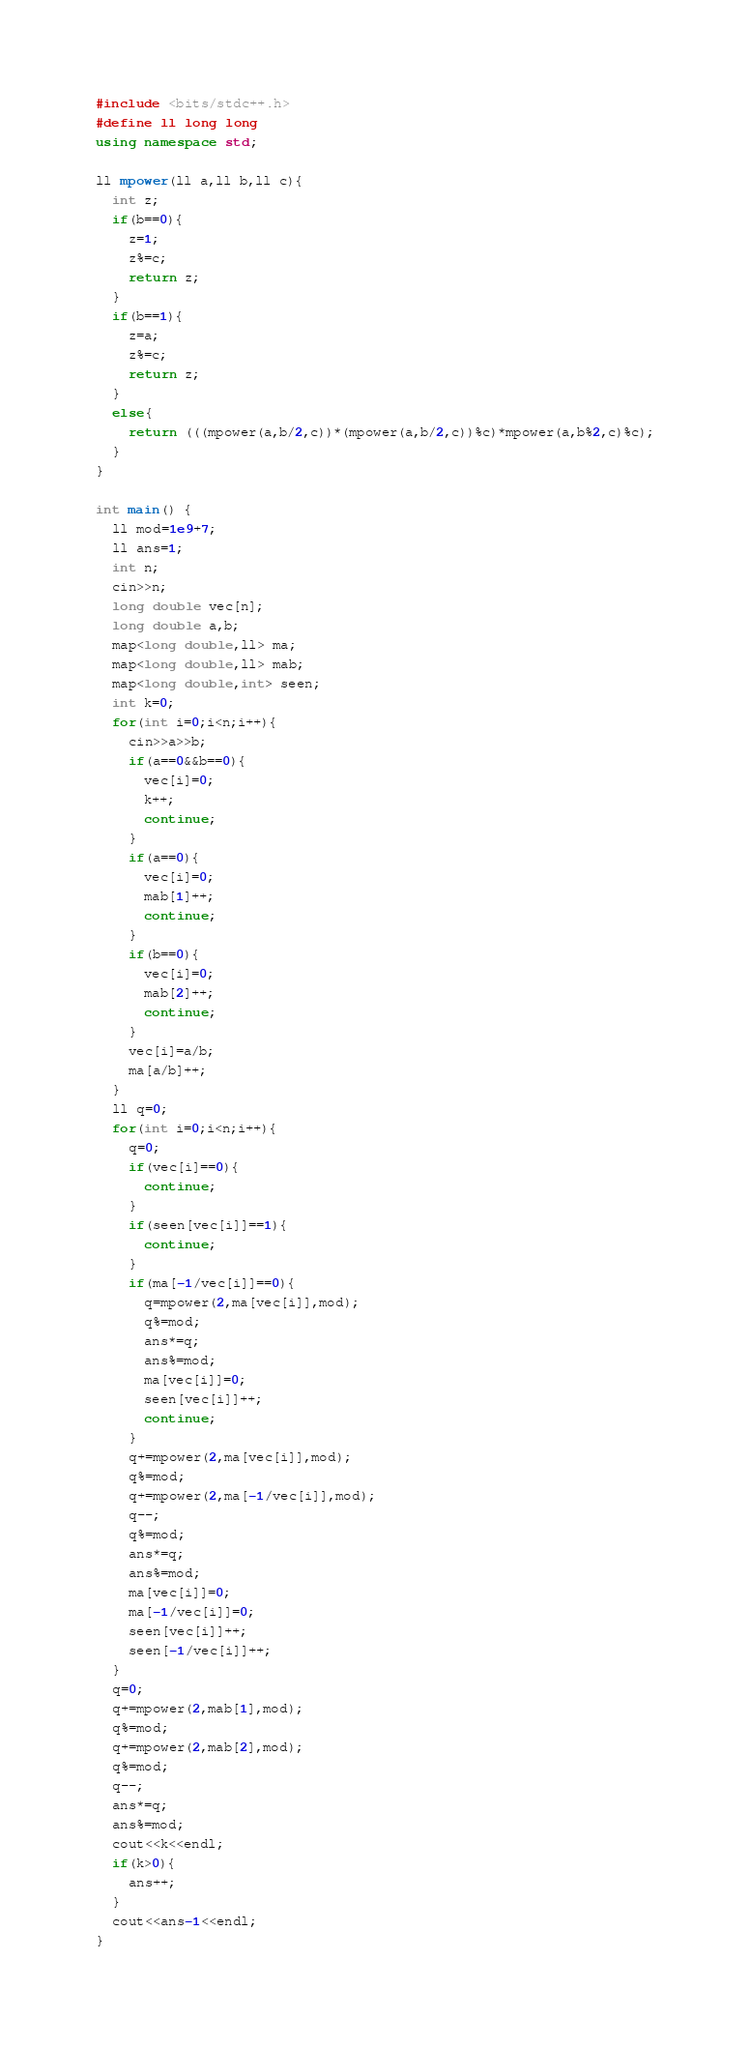Convert code to text. <code><loc_0><loc_0><loc_500><loc_500><_C++_>#include <bits/stdc++.h>
#define ll long long
using namespace std;

ll mpower(ll a,ll b,ll c){
  int z;
  if(b==0){
    z=1;
    z%=c;
    return z;
  }
  if(b==1){
    z=a;
    z%=c;
    return z;
  }
  else{
    return (((mpower(a,b/2,c))*(mpower(a,b/2,c))%c)*mpower(a,b%2,c)%c);
  }
}

int main() {
  ll mod=1e9+7;
  ll ans=1;
  int n;
  cin>>n;
  long double vec[n];
  long double a,b;
  map<long double,ll> ma;
  map<long double,ll> mab;
  map<long double,int> seen;
  int k=0;
  for(int i=0;i<n;i++){
    cin>>a>>b;
    if(a==0&&b==0){
      vec[i]=0;
      k++;
      continue;
    }
    if(a==0){
      vec[i]=0;
      mab[1]++;
      continue;
    }
    if(b==0){
      vec[i]=0;
      mab[2]++;
      continue;
    }
    vec[i]=a/b;
    ma[a/b]++;
  }
  ll q=0;
  for(int i=0;i<n;i++){
    q=0;
    if(vec[i]==0){
      continue;
    }
    if(seen[vec[i]]==1){
      continue;
    }
    if(ma[-1/vec[i]]==0){
      q=mpower(2,ma[vec[i]],mod);
      q%=mod;
      ans*=q;
      ans%=mod;
      ma[vec[i]]=0;
      seen[vec[i]]++;
      continue;
    }
    q+=mpower(2,ma[vec[i]],mod);
    q%=mod;
    q+=mpower(2,ma[-1/vec[i]],mod);
    q--;
    q%=mod;
    ans*=q;
    ans%=mod;
    ma[vec[i]]=0;
    ma[-1/vec[i]]=0;
    seen[vec[i]]++;
    seen[-1/vec[i]]++;
  }
  q=0;
  q+=mpower(2,mab[1],mod);
  q%=mod;
  q+=mpower(2,mab[2],mod);
  q%=mod;
  q--;
  ans*=q;
  ans%=mod;
  cout<<k<<endl;
  if(k>0){
    ans++;
  }
  cout<<ans-1<<endl;
}</code> 